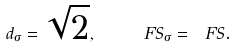Convert formula to latex. <formula><loc_0><loc_0><loc_500><loc_500>d _ { \sigma } = \sqrt { 2 } , \quad \ F S _ { \sigma } = \ F S .</formula> 